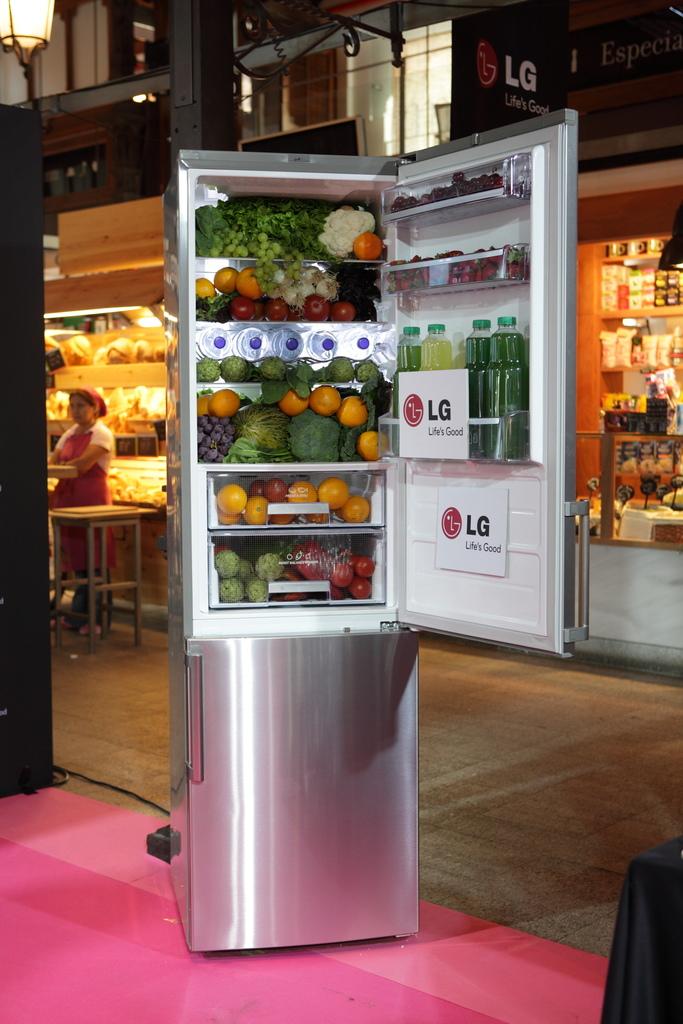What company makes this fridge?
Give a very brief answer. Lg. 